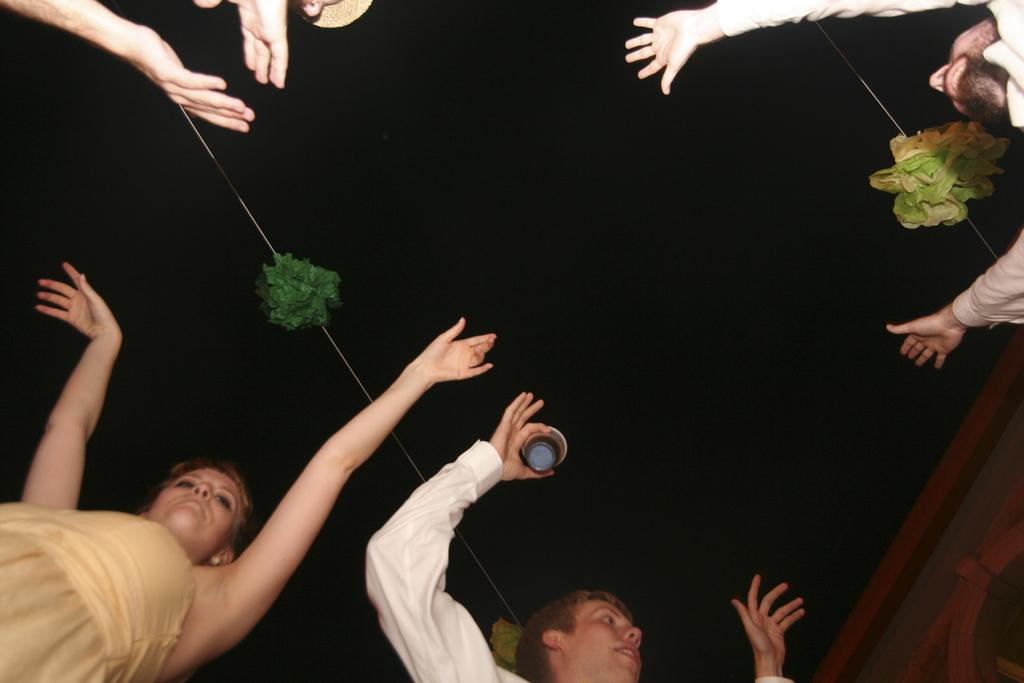How many people are in the image? There are people in the image, but the exact number is not specified. What is the person holding in the image? There is a person holding an object in the image, but the object is not described. Can you describe the other objects in the image? There are other objects in the image, but their specific details are not provided. What can be seen in the background of the image? The background of the image has a dark view. What type of train ticket is being offered in the image? There is no train ticket or offer present in the image. What type of offer is being made by the person holding the object in the image? There is no offer being made in the image, as the object being held is not described. 